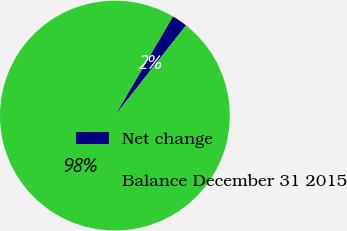Convert chart to OTSL. <chart><loc_0><loc_0><loc_500><loc_500><pie_chart><fcel>Net change<fcel>Balance December 31 2015<nl><fcel>2.21%<fcel>97.79%<nl></chart> 